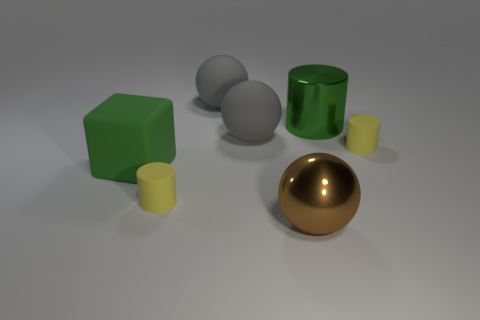How many gray balls must be subtracted to get 1 gray balls? 1 Subtract 1 balls. How many balls are left? 2 Add 3 large green objects. How many objects exist? 10 Subtract all green cylinders. How many cylinders are left? 2 Subtract all big brown spheres. How many spheres are left? 2 Subtract all cyan cylinders. Subtract all red spheres. How many cylinders are left? 3 Subtract all brown spheres. How many purple cubes are left? 0 Subtract all yellow rubber objects. Subtract all big metallic objects. How many objects are left? 3 Add 7 green matte objects. How many green matte objects are left? 8 Add 7 brown metallic spheres. How many brown metallic spheres exist? 8 